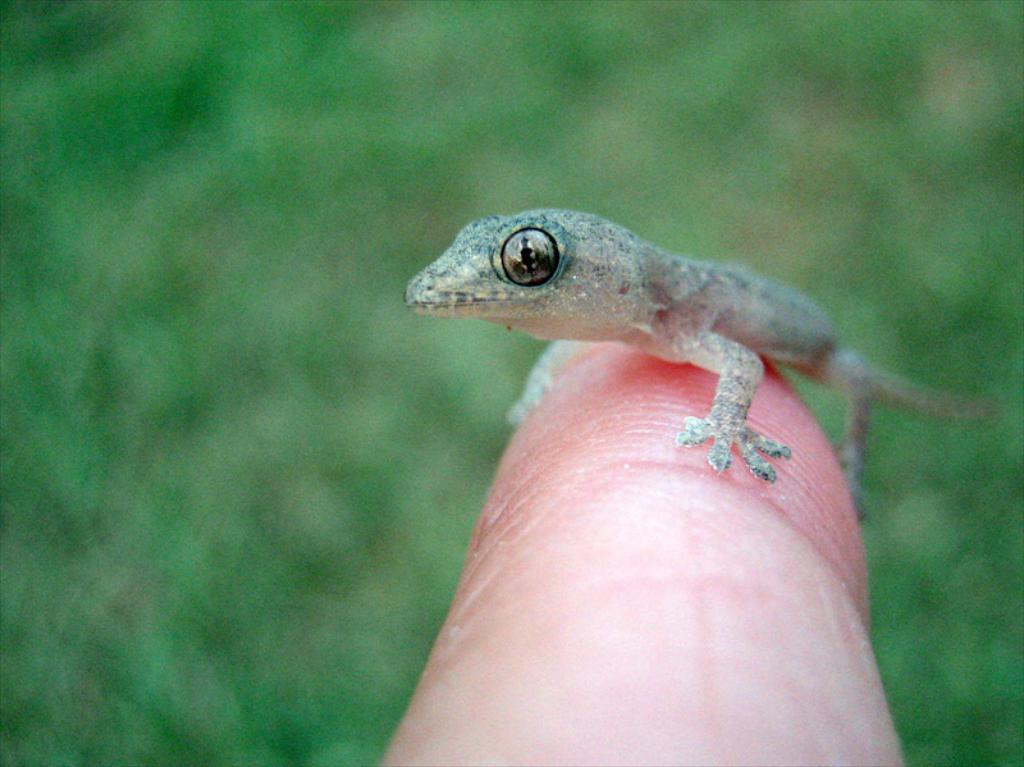Describe this image in one or two sentences. In this image I can see a lizard which is in grey color. The lizard is on the person finger. Background is in green color. 